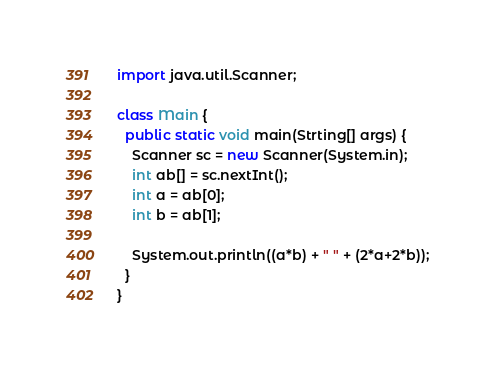<code> <loc_0><loc_0><loc_500><loc_500><_Java_>import java.util.Scanner;

class Main {
  public static void main(Strting[] args) {
    Scanner sc = new Scanner(System.in);
    int ab[] = sc.nextInt();
    int a = ab[0];
    int b = ab[1];

    System.out.println((a*b) + " " + (2*a+2*b));
  }
}
</code> 